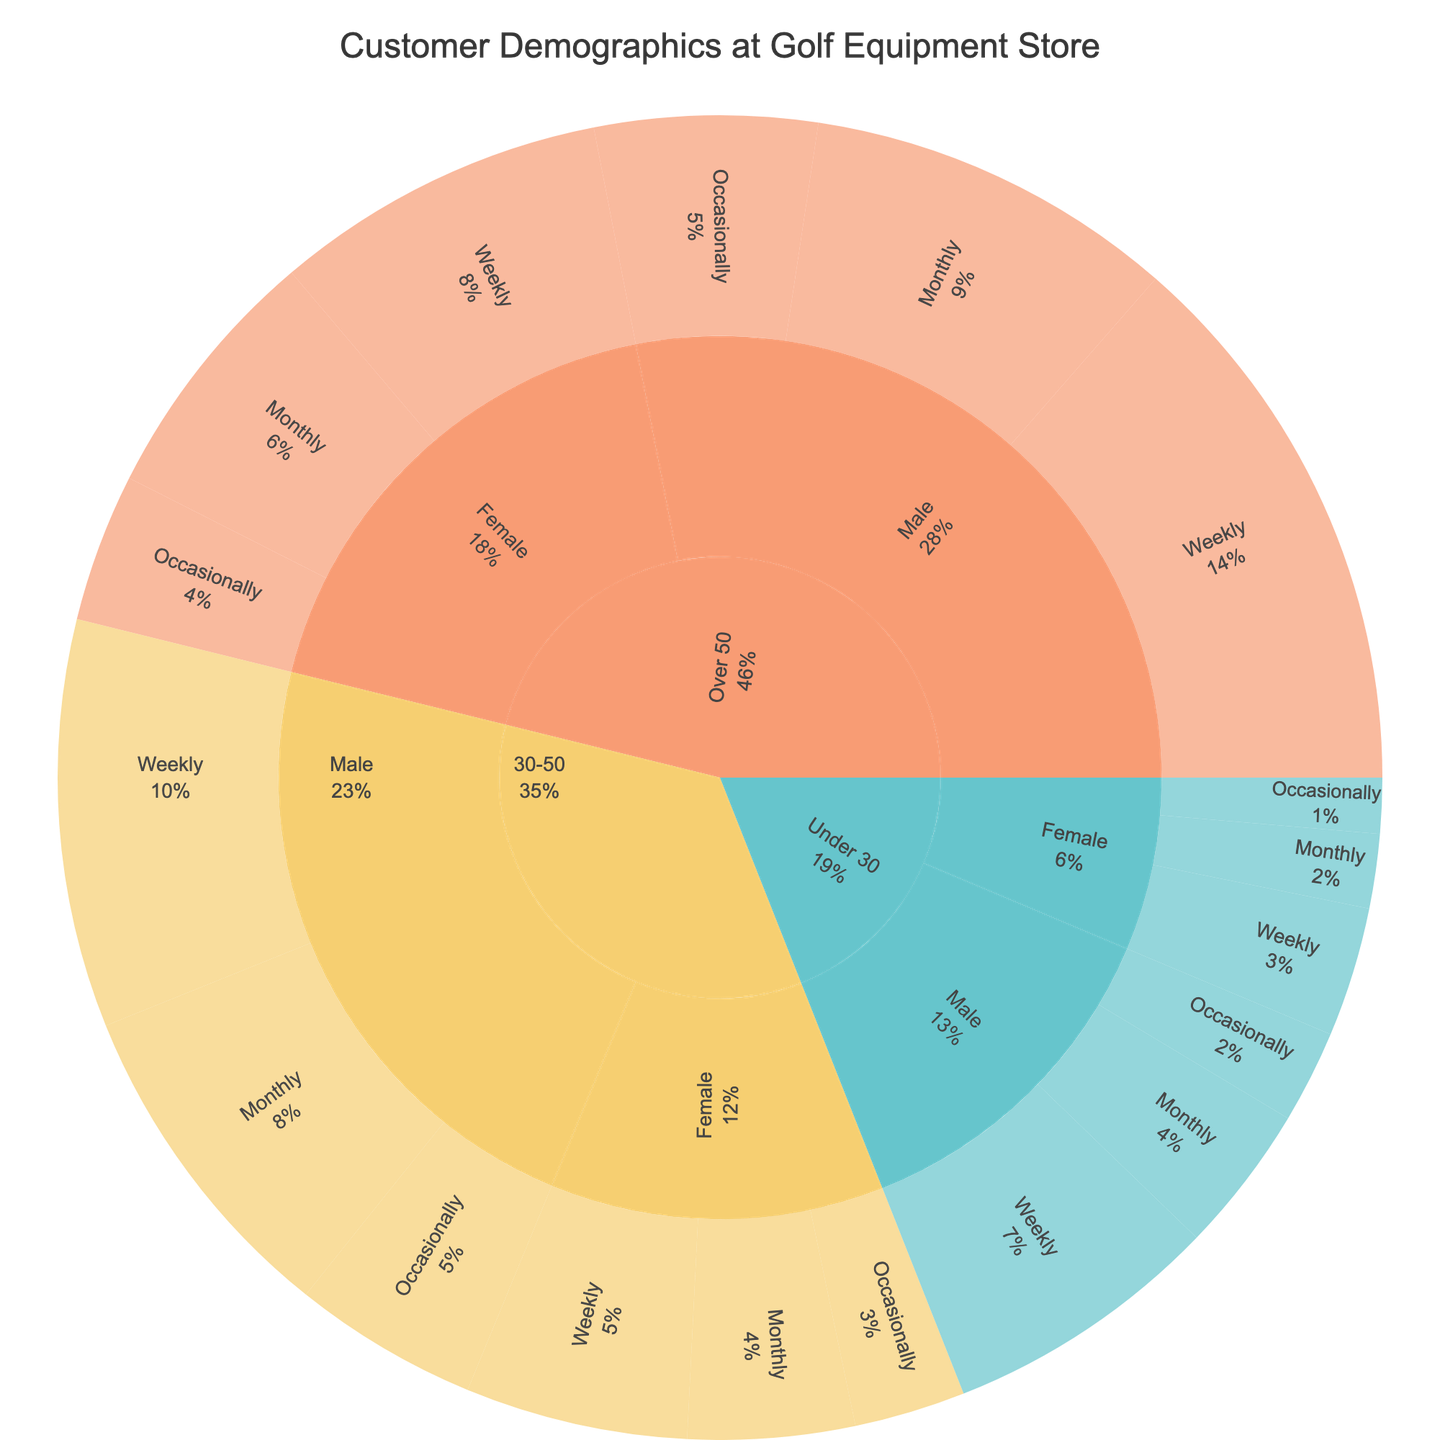What is the title of the Sunburst Plot? The title is typically placed prominently at the top of the plot and clearly states what the figure represents.
Answer: "Customer Demographics at Golf Equipment Store" Which age group has the highest total number of customers? Sum the values for each age group: Under 30 (15+8+5+7+4+3=42), 30-50 (22+18+10+12+9+6=77), Over 50 (30+20+12+18+14+8=102). The Over 50 group has the highest total.
Answer: Over 50 In the Over 50 age group, which gender has the higher value for Weekly playing frequency? Look at the Over 50 age group and compare the Weekly values for Male and Female: Male (30), Female (18). Male has the higher value.
Answer: Male What is the percentage of Female customers in the 30-50 age group who play Monthly? Find the value for Female customers playing Monthly in the 30-50 age group (9). Then, sum the total values for Female in 30-50 (12+9+6=27) and divide (9/27), giving approximately 33.33%.
Answer: ~33.33% Compare the number of Male customers in the Under 30 group who play Weekly to those who play Monthly. Look at the values: Weekly (15) and Monthly (8) in the Under 30, Male group. There are more customers who play Weekly.
Answer: Weekly What is the combined total number of customers who play Occasionally in the 30-50 and Over 50 age groups? Sum the Occasionally values for both age groups: 30-50 (10+6=16), Over 50 (12+8=20). Then add them together (16+20=36).
Answer: 36 Which playing frequency has the lowest number of customers in the Under 30, Female group? Look at the values for Weekly (7), Monthly (4), and Occasionally (3). Occasionally has the lowest value.
Answer: Occasionally How many more customers in the Over 50 group play Weekly compared to those in the 30-50 group who play Monthly? In the Over 50 group, Weekly (30); in the 30-50 group, Monthly (18). Subtract to find the difference (30-18=12).
Answer: 12 What is the sum of customers who are Male and play Weekly across all age groups? Sum the Weekly values for Male in all age groups: Under 30 (15), 30-50 (22), Over 50 (30). Total = (15+22+30=67).
Answer: 67 Which age and gender combination has the highest value for Monthly playing frequency? Compare the Monthly values: Under 30, Male (8); Under 30, Female (4); 30-50, Male (18); 30-50, Female (9); Over 50, Male (20); Over 50, Female (14). The highest value is Over 50, Male (20).
Answer: Over 50, Male 